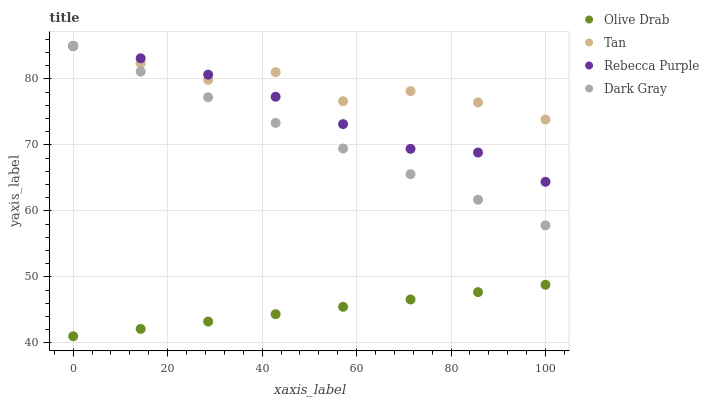Does Olive Drab have the minimum area under the curve?
Answer yes or no. Yes. Does Tan have the maximum area under the curve?
Answer yes or no. Yes. Does Rebecca Purple have the minimum area under the curve?
Answer yes or no. No. Does Rebecca Purple have the maximum area under the curve?
Answer yes or no. No. Is Olive Drab the smoothest?
Answer yes or no. Yes. Is Tan the roughest?
Answer yes or no. Yes. Is Rebecca Purple the smoothest?
Answer yes or no. No. Is Rebecca Purple the roughest?
Answer yes or no. No. Does Olive Drab have the lowest value?
Answer yes or no. Yes. Does Rebecca Purple have the lowest value?
Answer yes or no. No. Does Rebecca Purple have the highest value?
Answer yes or no. Yes. Does Olive Drab have the highest value?
Answer yes or no. No. Is Olive Drab less than Dark Gray?
Answer yes or no. Yes. Is Tan greater than Olive Drab?
Answer yes or no. Yes. Does Dark Gray intersect Rebecca Purple?
Answer yes or no. Yes. Is Dark Gray less than Rebecca Purple?
Answer yes or no. No. Is Dark Gray greater than Rebecca Purple?
Answer yes or no. No. Does Olive Drab intersect Dark Gray?
Answer yes or no. No. 